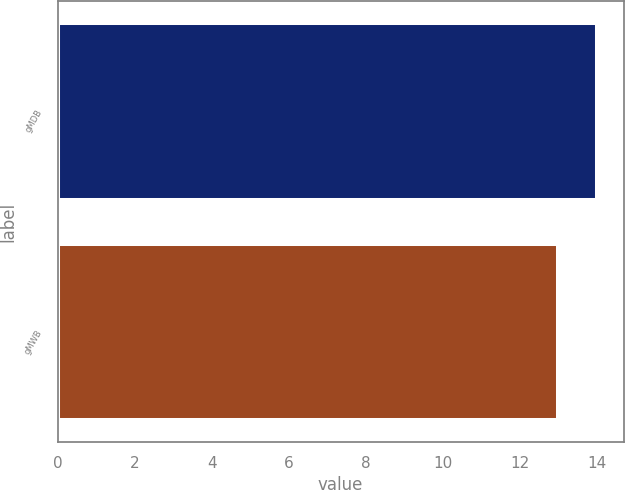<chart> <loc_0><loc_0><loc_500><loc_500><bar_chart><fcel>gMDB<fcel>gMWB<nl><fcel>14<fcel>13<nl></chart> 